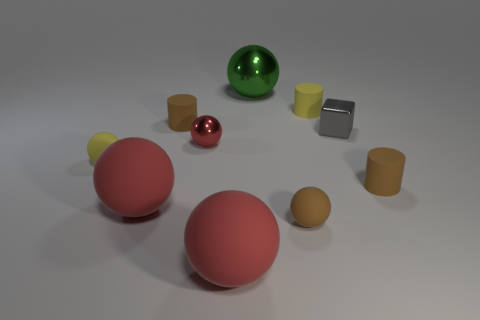There is a large ball that is behind the metallic cube; what is it made of?
Offer a terse response. Metal. Is the number of yellow objects less than the number of big balls?
Provide a short and direct response. Yes. The big object that is both in front of the tiny red shiny object and on the right side of the tiny metal ball has what shape?
Keep it short and to the point. Sphere. How many tiny cyan rubber balls are there?
Your response must be concise. 0. The tiny brown cylinder to the right of the shiny sphere that is behind the tiny yellow object that is right of the brown ball is made of what material?
Provide a short and direct response. Rubber. There is a tiny rubber cylinder that is left of the small red sphere; what number of big red things are on the right side of it?
Provide a succinct answer. 1. What color is the other small metallic object that is the same shape as the green shiny object?
Offer a very short reply. Red. Is the block made of the same material as the tiny yellow cylinder?
Make the answer very short. No. What number of cylinders are tiny green metallic objects or small gray objects?
Your answer should be compact. 0. What is the size of the sphere behind the tiny shiny object to the right of the metal ball that is behind the tiny gray shiny thing?
Your answer should be compact. Large. 